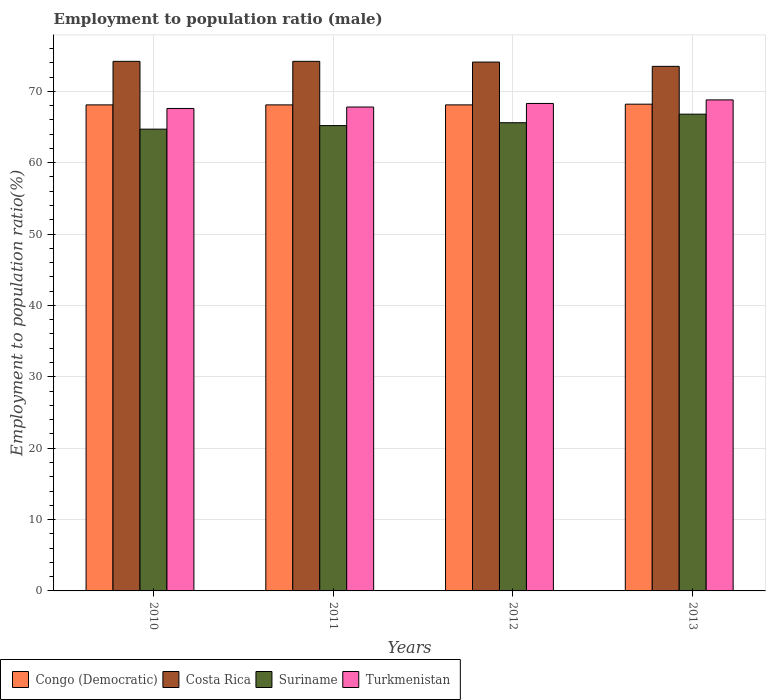How many different coloured bars are there?
Your answer should be very brief. 4. How many groups of bars are there?
Your response must be concise. 4. Are the number of bars per tick equal to the number of legend labels?
Provide a succinct answer. Yes. Are the number of bars on each tick of the X-axis equal?
Provide a short and direct response. Yes. How many bars are there on the 2nd tick from the left?
Give a very brief answer. 4. In how many cases, is the number of bars for a given year not equal to the number of legend labels?
Offer a terse response. 0. What is the employment to population ratio in Turkmenistan in 2012?
Ensure brevity in your answer.  68.3. Across all years, what is the maximum employment to population ratio in Turkmenistan?
Keep it short and to the point. 68.8. Across all years, what is the minimum employment to population ratio in Suriname?
Make the answer very short. 64.7. In which year was the employment to population ratio in Suriname maximum?
Keep it short and to the point. 2013. In which year was the employment to population ratio in Turkmenistan minimum?
Your answer should be compact. 2010. What is the total employment to population ratio in Suriname in the graph?
Provide a succinct answer. 262.3. What is the difference between the employment to population ratio in Turkmenistan in 2010 and that in 2011?
Provide a short and direct response. -0.2. What is the difference between the employment to population ratio in Suriname in 2011 and the employment to population ratio in Turkmenistan in 2013?
Offer a terse response. -3.6. What is the average employment to population ratio in Turkmenistan per year?
Keep it short and to the point. 68.13. In the year 2010, what is the difference between the employment to population ratio in Costa Rica and employment to population ratio in Turkmenistan?
Keep it short and to the point. 6.6. What is the ratio of the employment to population ratio in Suriname in 2010 to that in 2011?
Your response must be concise. 0.99. Is the employment to population ratio in Suriname in 2010 less than that in 2012?
Keep it short and to the point. Yes. Is the difference between the employment to population ratio in Costa Rica in 2011 and 2013 greater than the difference between the employment to population ratio in Turkmenistan in 2011 and 2013?
Make the answer very short. Yes. What is the difference between the highest and the second highest employment to population ratio in Congo (Democratic)?
Provide a succinct answer. 0.1. What is the difference between the highest and the lowest employment to population ratio in Suriname?
Ensure brevity in your answer.  2.1. In how many years, is the employment to population ratio in Turkmenistan greater than the average employment to population ratio in Turkmenistan taken over all years?
Give a very brief answer. 2. What does the 1st bar from the left in 2010 represents?
Offer a very short reply. Congo (Democratic). What does the 2nd bar from the right in 2012 represents?
Your answer should be compact. Suriname. Is it the case that in every year, the sum of the employment to population ratio in Congo (Democratic) and employment to population ratio in Suriname is greater than the employment to population ratio in Turkmenistan?
Your answer should be compact. Yes. How many years are there in the graph?
Offer a terse response. 4. What is the difference between two consecutive major ticks on the Y-axis?
Give a very brief answer. 10. Are the values on the major ticks of Y-axis written in scientific E-notation?
Give a very brief answer. No. Where does the legend appear in the graph?
Offer a terse response. Bottom left. How many legend labels are there?
Your answer should be compact. 4. How are the legend labels stacked?
Provide a short and direct response. Horizontal. What is the title of the graph?
Make the answer very short. Employment to population ratio (male). Does "World" appear as one of the legend labels in the graph?
Your answer should be compact. No. What is the Employment to population ratio(%) in Congo (Democratic) in 2010?
Offer a very short reply. 68.1. What is the Employment to population ratio(%) in Costa Rica in 2010?
Your response must be concise. 74.2. What is the Employment to population ratio(%) of Suriname in 2010?
Provide a short and direct response. 64.7. What is the Employment to population ratio(%) in Turkmenistan in 2010?
Your response must be concise. 67.6. What is the Employment to population ratio(%) of Congo (Democratic) in 2011?
Your answer should be very brief. 68.1. What is the Employment to population ratio(%) of Costa Rica in 2011?
Make the answer very short. 74.2. What is the Employment to population ratio(%) of Suriname in 2011?
Ensure brevity in your answer.  65.2. What is the Employment to population ratio(%) of Turkmenistan in 2011?
Provide a short and direct response. 67.8. What is the Employment to population ratio(%) in Congo (Democratic) in 2012?
Provide a succinct answer. 68.1. What is the Employment to population ratio(%) in Costa Rica in 2012?
Keep it short and to the point. 74.1. What is the Employment to population ratio(%) in Suriname in 2012?
Give a very brief answer. 65.6. What is the Employment to population ratio(%) in Turkmenistan in 2012?
Your answer should be very brief. 68.3. What is the Employment to population ratio(%) of Congo (Democratic) in 2013?
Ensure brevity in your answer.  68.2. What is the Employment to population ratio(%) of Costa Rica in 2013?
Provide a succinct answer. 73.5. What is the Employment to population ratio(%) in Suriname in 2013?
Ensure brevity in your answer.  66.8. What is the Employment to population ratio(%) in Turkmenistan in 2013?
Your answer should be compact. 68.8. Across all years, what is the maximum Employment to population ratio(%) of Congo (Democratic)?
Ensure brevity in your answer.  68.2. Across all years, what is the maximum Employment to population ratio(%) in Costa Rica?
Provide a short and direct response. 74.2. Across all years, what is the maximum Employment to population ratio(%) of Suriname?
Your answer should be compact. 66.8. Across all years, what is the maximum Employment to population ratio(%) of Turkmenistan?
Your response must be concise. 68.8. Across all years, what is the minimum Employment to population ratio(%) in Congo (Democratic)?
Ensure brevity in your answer.  68.1. Across all years, what is the minimum Employment to population ratio(%) of Costa Rica?
Provide a short and direct response. 73.5. Across all years, what is the minimum Employment to population ratio(%) in Suriname?
Provide a succinct answer. 64.7. Across all years, what is the minimum Employment to population ratio(%) in Turkmenistan?
Offer a terse response. 67.6. What is the total Employment to population ratio(%) of Congo (Democratic) in the graph?
Make the answer very short. 272.5. What is the total Employment to population ratio(%) of Costa Rica in the graph?
Offer a very short reply. 296. What is the total Employment to population ratio(%) in Suriname in the graph?
Offer a terse response. 262.3. What is the total Employment to population ratio(%) of Turkmenistan in the graph?
Ensure brevity in your answer.  272.5. What is the difference between the Employment to population ratio(%) in Congo (Democratic) in 2010 and that in 2011?
Your response must be concise. 0. What is the difference between the Employment to population ratio(%) of Suriname in 2010 and that in 2011?
Keep it short and to the point. -0.5. What is the difference between the Employment to population ratio(%) in Congo (Democratic) in 2010 and that in 2012?
Keep it short and to the point. 0. What is the difference between the Employment to population ratio(%) of Suriname in 2010 and that in 2012?
Give a very brief answer. -0.9. What is the difference between the Employment to population ratio(%) in Costa Rica in 2010 and that in 2013?
Provide a succinct answer. 0.7. What is the difference between the Employment to population ratio(%) of Suriname in 2010 and that in 2013?
Provide a short and direct response. -2.1. What is the difference between the Employment to population ratio(%) of Congo (Democratic) in 2011 and that in 2012?
Ensure brevity in your answer.  0. What is the difference between the Employment to population ratio(%) of Costa Rica in 2011 and that in 2012?
Offer a very short reply. 0.1. What is the difference between the Employment to population ratio(%) in Turkmenistan in 2011 and that in 2012?
Provide a short and direct response. -0.5. What is the difference between the Employment to population ratio(%) of Congo (Democratic) in 2011 and that in 2013?
Your answer should be very brief. -0.1. What is the difference between the Employment to population ratio(%) of Suriname in 2011 and that in 2013?
Offer a terse response. -1.6. What is the difference between the Employment to population ratio(%) of Turkmenistan in 2011 and that in 2013?
Give a very brief answer. -1. What is the difference between the Employment to population ratio(%) in Congo (Democratic) in 2012 and that in 2013?
Your answer should be very brief. -0.1. What is the difference between the Employment to population ratio(%) in Costa Rica in 2012 and that in 2013?
Your response must be concise. 0.6. What is the difference between the Employment to population ratio(%) of Turkmenistan in 2012 and that in 2013?
Offer a terse response. -0.5. What is the difference between the Employment to population ratio(%) of Congo (Democratic) in 2010 and the Employment to population ratio(%) of Costa Rica in 2011?
Your answer should be compact. -6.1. What is the difference between the Employment to population ratio(%) of Congo (Democratic) in 2010 and the Employment to population ratio(%) of Turkmenistan in 2011?
Make the answer very short. 0.3. What is the difference between the Employment to population ratio(%) of Costa Rica in 2010 and the Employment to population ratio(%) of Suriname in 2011?
Make the answer very short. 9. What is the difference between the Employment to population ratio(%) of Suriname in 2010 and the Employment to population ratio(%) of Turkmenistan in 2011?
Keep it short and to the point. -3.1. What is the difference between the Employment to population ratio(%) of Congo (Democratic) in 2010 and the Employment to population ratio(%) of Costa Rica in 2012?
Your answer should be very brief. -6. What is the difference between the Employment to population ratio(%) of Costa Rica in 2010 and the Employment to population ratio(%) of Turkmenistan in 2012?
Ensure brevity in your answer.  5.9. What is the difference between the Employment to population ratio(%) in Suriname in 2010 and the Employment to population ratio(%) in Turkmenistan in 2012?
Give a very brief answer. -3.6. What is the difference between the Employment to population ratio(%) of Congo (Democratic) in 2010 and the Employment to population ratio(%) of Costa Rica in 2013?
Make the answer very short. -5.4. What is the difference between the Employment to population ratio(%) in Costa Rica in 2010 and the Employment to population ratio(%) in Suriname in 2013?
Offer a very short reply. 7.4. What is the difference between the Employment to population ratio(%) in Suriname in 2010 and the Employment to population ratio(%) in Turkmenistan in 2013?
Ensure brevity in your answer.  -4.1. What is the difference between the Employment to population ratio(%) of Costa Rica in 2011 and the Employment to population ratio(%) of Suriname in 2012?
Offer a terse response. 8.6. What is the difference between the Employment to population ratio(%) in Costa Rica in 2011 and the Employment to population ratio(%) in Turkmenistan in 2012?
Make the answer very short. 5.9. What is the difference between the Employment to population ratio(%) of Suriname in 2011 and the Employment to population ratio(%) of Turkmenistan in 2012?
Your answer should be very brief. -3.1. What is the difference between the Employment to population ratio(%) of Congo (Democratic) in 2011 and the Employment to population ratio(%) of Suriname in 2013?
Give a very brief answer. 1.3. What is the difference between the Employment to population ratio(%) in Congo (Democratic) in 2012 and the Employment to population ratio(%) in Turkmenistan in 2013?
Offer a terse response. -0.7. What is the difference between the Employment to population ratio(%) in Costa Rica in 2012 and the Employment to population ratio(%) in Turkmenistan in 2013?
Give a very brief answer. 5.3. What is the difference between the Employment to population ratio(%) in Suriname in 2012 and the Employment to population ratio(%) in Turkmenistan in 2013?
Make the answer very short. -3.2. What is the average Employment to population ratio(%) of Congo (Democratic) per year?
Your answer should be compact. 68.12. What is the average Employment to population ratio(%) in Suriname per year?
Make the answer very short. 65.58. What is the average Employment to population ratio(%) in Turkmenistan per year?
Make the answer very short. 68.12. In the year 2010, what is the difference between the Employment to population ratio(%) of Congo (Democratic) and Employment to population ratio(%) of Costa Rica?
Your answer should be compact. -6.1. In the year 2010, what is the difference between the Employment to population ratio(%) of Suriname and Employment to population ratio(%) of Turkmenistan?
Your answer should be very brief. -2.9. In the year 2011, what is the difference between the Employment to population ratio(%) in Congo (Democratic) and Employment to population ratio(%) in Costa Rica?
Your response must be concise. -6.1. In the year 2011, what is the difference between the Employment to population ratio(%) in Congo (Democratic) and Employment to population ratio(%) in Suriname?
Offer a very short reply. 2.9. In the year 2011, what is the difference between the Employment to population ratio(%) in Congo (Democratic) and Employment to population ratio(%) in Turkmenistan?
Your answer should be compact. 0.3. In the year 2011, what is the difference between the Employment to population ratio(%) in Costa Rica and Employment to population ratio(%) in Suriname?
Provide a succinct answer. 9. In the year 2011, what is the difference between the Employment to population ratio(%) of Costa Rica and Employment to population ratio(%) of Turkmenistan?
Your answer should be compact. 6.4. In the year 2012, what is the difference between the Employment to population ratio(%) of Congo (Democratic) and Employment to population ratio(%) of Costa Rica?
Keep it short and to the point. -6. In the year 2012, what is the difference between the Employment to population ratio(%) in Congo (Democratic) and Employment to population ratio(%) in Turkmenistan?
Give a very brief answer. -0.2. In the year 2012, what is the difference between the Employment to population ratio(%) in Costa Rica and Employment to population ratio(%) in Suriname?
Give a very brief answer. 8.5. In the year 2012, what is the difference between the Employment to population ratio(%) of Suriname and Employment to population ratio(%) of Turkmenistan?
Make the answer very short. -2.7. In the year 2013, what is the difference between the Employment to population ratio(%) of Congo (Democratic) and Employment to population ratio(%) of Turkmenistan?
Offer a terse response. -0.6. In the year 2013, what is the difference between the Employment to population ratio(%) in Suriname and Employment to population ratio(%) in Turkmenistan?
Your answer should be very brief. -2. What is the ratio of the Employment to population ratio(%) in Congo (Democratic) in 2010 to that in 2011?
Your response must be concise. 1. What is the ratio of the Employment to population ratio(%) of Suriname in 2010 to that in 2012?
Offer a very short reply. 0.99. What is the ratio of the Employment to population ratio(%) of Turkmenistan in 2010 to that in 2012?
Your answer should be very brief. 0.99. What is the ratio of the Employment to population ratio(%) of Costa Rica in 2010 to that in 2013?
Provide a succinct answer. 1.01. What is the ratio of the Employment to population ratio(%) in Suriname in 2010 to that in 2013?
Your answer should be compact. 0.97. What is the ratio of the Employment to population ratio(%) in Turkmenistan in 2010 to that in 2013?
Offer a very short reply. 0.98. What is the ratio of the Employment to population ratio(%) in Congo (Democratic) in 2011 to that in 2012?
Your response must be concise. 1. What is the ratio of the Employment to population ratio(%) in Suriname in 2011 to that in 2012?
Offer a terse response. 0.99. What is the ratio of the Employment to population ratio(%) in Congo (Democratic) in 2011 to that in 2013?
Make the answer very short. 1. What is the ratio of the Employment to population ratio(%) of Costa Rica in 2011 to that in 2013?
Provide a succinct answer. 1.01. What is the ratio of the Employment to population ratio(%) of Suriname in 2011 to that in 2013?
Ensure brevity in your answer.  0.98. What is the ratio of the Employment to population ratio(%) in Turkmenistan in 2011 to that in 2013?
Ensure brevity in your answer.  0.99. What is the ratio of the Employment to population ratio(%) of Costa Rica in 2012 to that in 2013?
Your answer should be very brief. 1.01. What is the ratio of the Employment to population ratio(%) of Turkmenistan in 2012 to that in 2013?
Your response must be concise. 0.99. What is the difference between the highest and the second highest Employment to population ratio(%) in Congo (Democratic)?
Give a very brief answer. 0.1. What is the difference between the highest and the second highest Employment to population ratio(%) of Suriname?
Your answer should be very brief. 1.2. What is the difference between the highest and the second highest Employment to population ratio(%) of Turkmenistan?
Provide a succinct answer. 0.5. What is the difference between the highest and the lowest Employment to population ratio(%) of Congo (Democratic)?
Your answer should be compact. 0.1. What is the difference between the highest and the lowest Employment to population ratio(%) in Suriname?
Offer a very short reply. 2.1. What is the difference between the highest and the lowest Employment to population ratio(%) in Turkmenistan?
Your answer should be very brief. 1.2. 